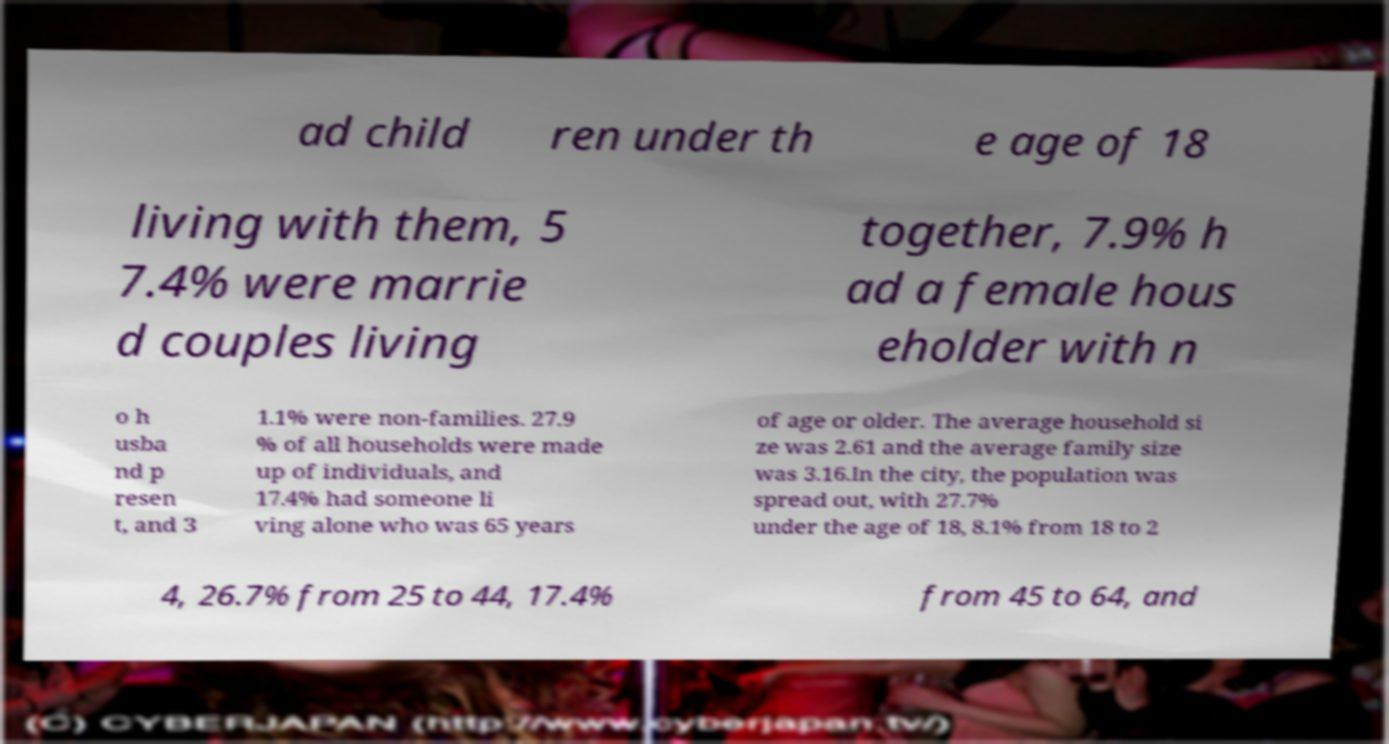There's text embedded in this image that I need extracted. Can you transcribe it verbatim? ad child ren under th e age of 18 living with them, 5 7.4% were marrie d couples living together, 7.9% h ad a female hous eholder with n o h usba nd p resen t, and 3 1.1% were non-families. 27.9 % of all households were made up of individuals, and 17.4% had someone li ving alone who was 65 years of age or older. The average household si ze was 2.61 and the average family size was 3.16.In the city, the population was spread out, with 27.7% under the age of 18, 8.1% from 18 to 2 4, 26.7% from 25 to 44, 17.4% from 45 to 64, and 